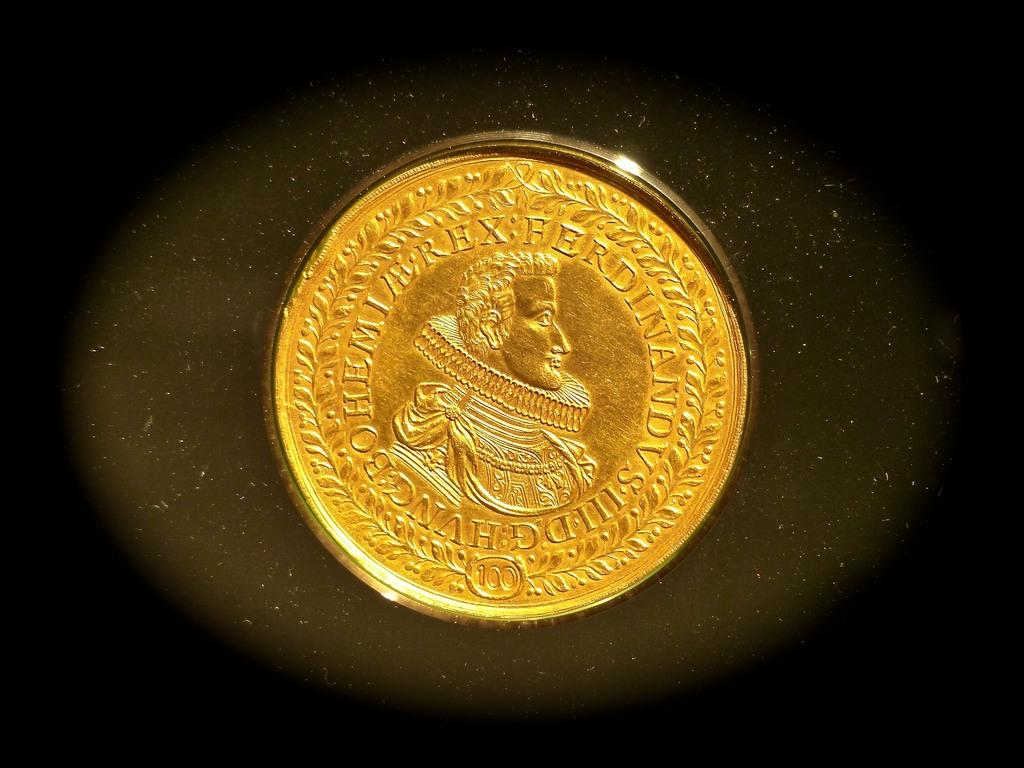What is the main subject in the image? There is an object in the image. Can you describe the background of the image? The background of the image is colored. Can you tell me how many trucks are visible in the image? There is no truck present in the image. What type of mineral is visible in the image? There is no mineral, such as quartz, present in the image. What type of transportation infrastructure is visible in the image? There is no railway or any other transportation infrastructure present in the image. 